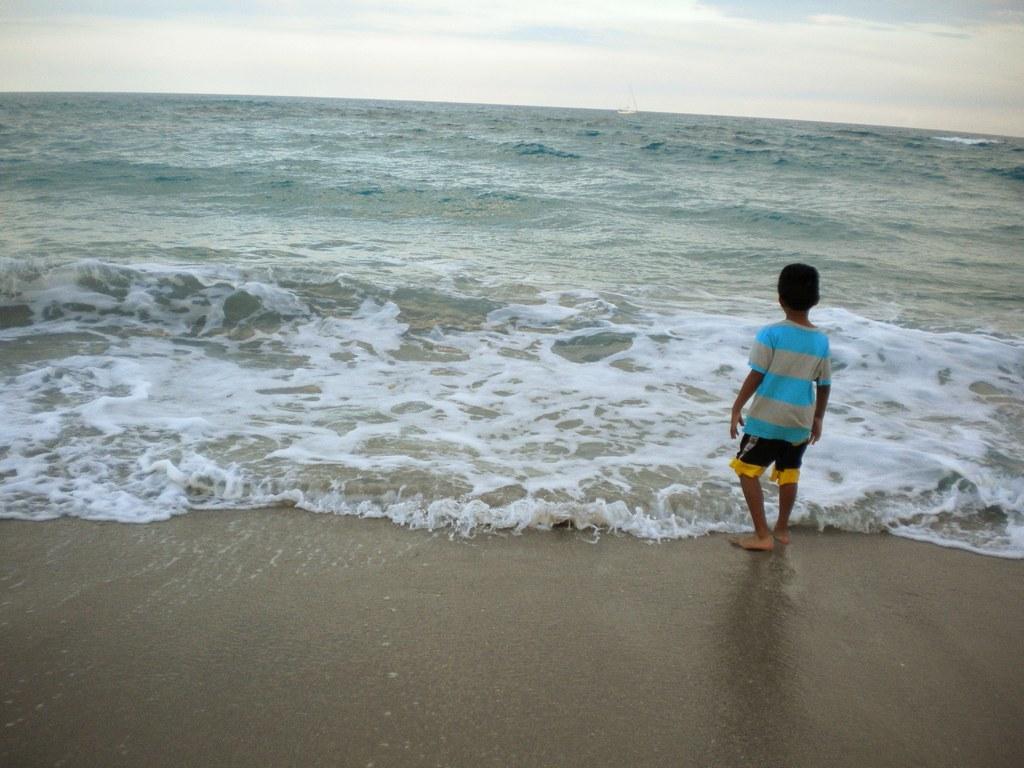How would you summarize this image in a sentence or two? In this image I can see the person standing in-front of the water. To person is wearing the blue, ash, black and yellow color dress. In the background I can see the sky. 